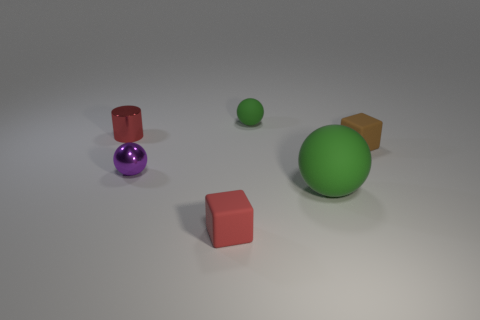Is the number of small green things that are in front of the big green rubber ball greater than the number of red cylinders?
Make the answer very short. No. How many things are either matte objects in front of the tiny red shiny cylinder or metallic things?
Your answer should be very brief. 5. How many small brown blocks are made of the same material as the cylinder?
Your answer should be very brief. 0. There is a big rubber thing that is the same color as the tiny rubber sphere; what shape is it?
Make the answer very short. Sphere. Are there any other objects of the same shape as the big green rubber object?
Give a very brief answer. Yes. What shape is the green object that is the same size as the brown matte cube?
Your response must be concise. Sphere. Does the metallic sphere have the same color as the sphere that is behind the small purple metallic sphere?
Provide a short and direct response. No. There is a green matte sphere in front of the tiny metal cylinder; how many tiny cubes are on the right side of it?
Offer a terse response. 1. There is a ball that is right of the red rubber cube and behind the large ball; what is its size?
Ensure brevity in your answer.  Small. Is there a red matte cube that has the same size as the purple thing?
Make the answer very short. Yes. 